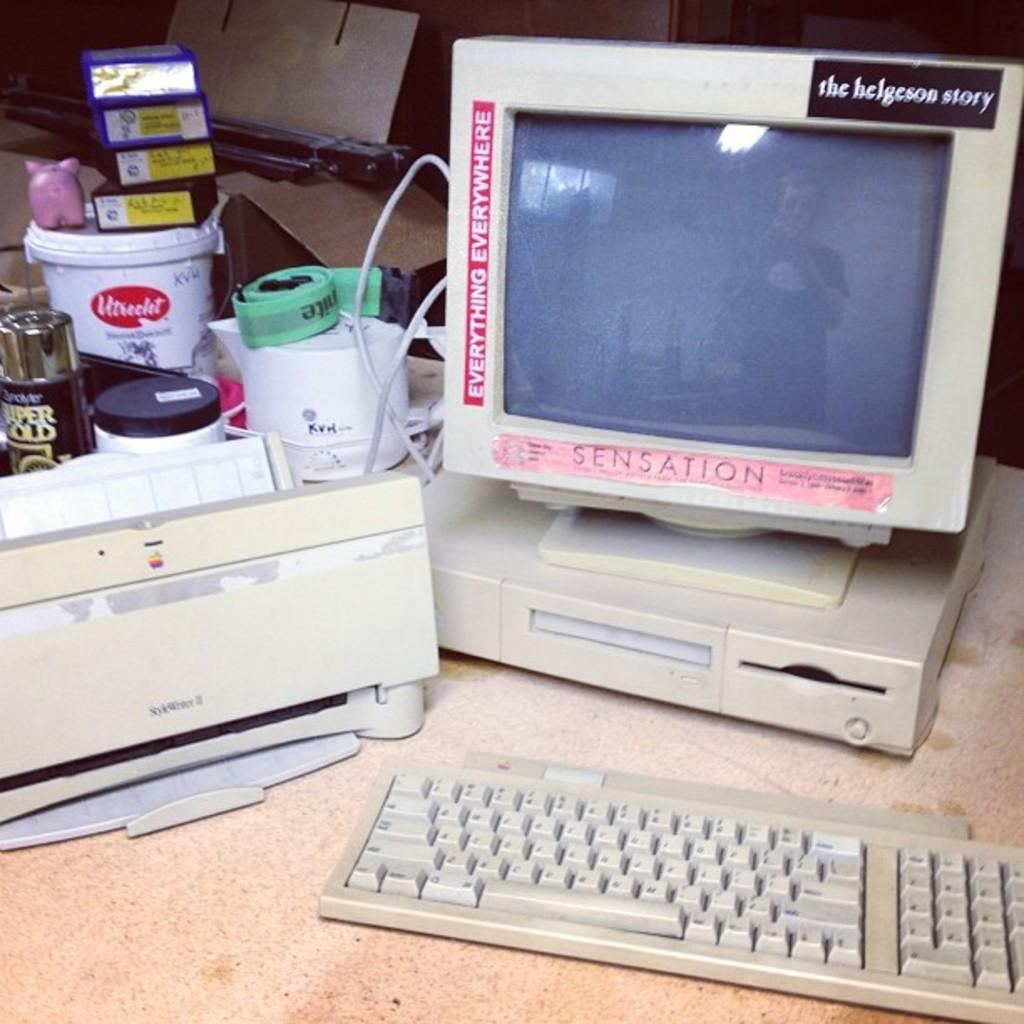Provide a one-sentence caption for the provided image. an old computer and monitor with a sensation sticker its border. 